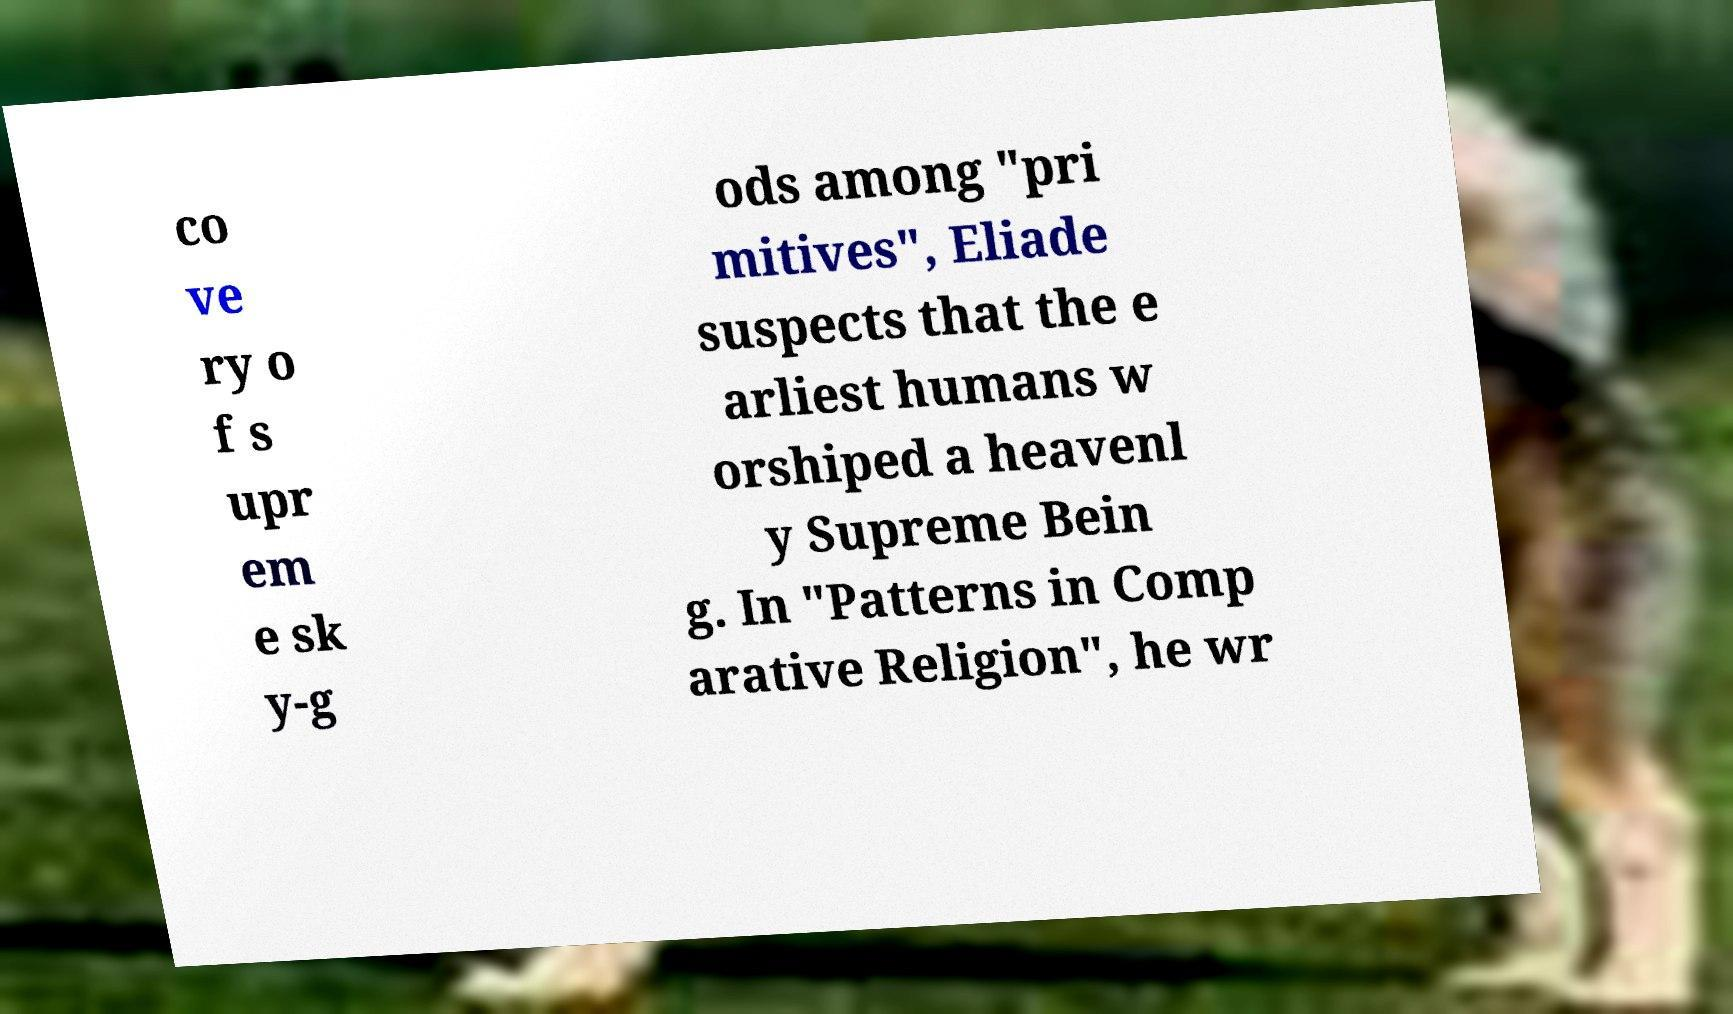For documentation purposes, I need the text within this image transcribed. Could you provide that? co ve ry o f s upr em e sk y-g ods among "pri mitives", Eliade suspects that the e arliest humans w orshiped a heavenl y Supreme Bein g. In "Patterns in Comp arative Religion", he wr 